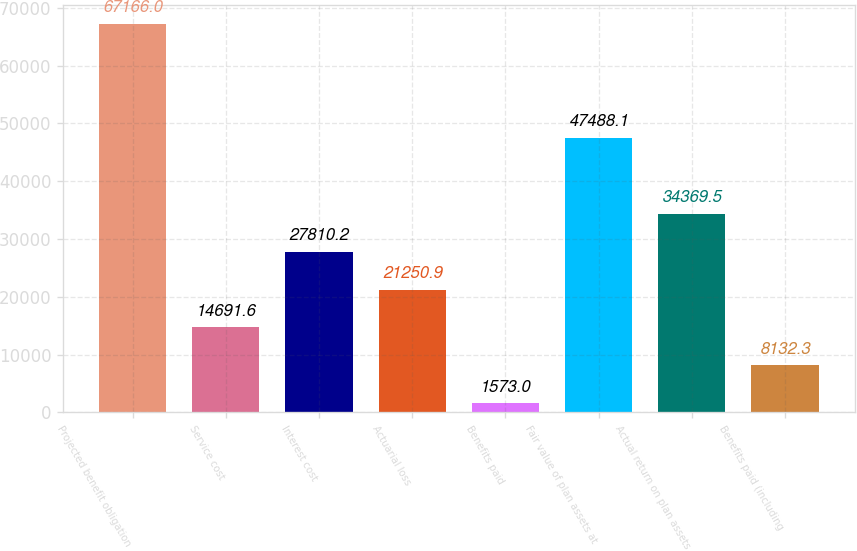Convert chart to OTSL. <chart><loc_0><loc_0><loc_500><loc_500><bar_chart><fcel>Projected benefit obligation<fcel>Service cost<fcel>Interest cost<fcel>Actuarial loss<fcel>Benefits paid<fcel>Fair value of plan assets at<fcel>Actual return on plan assets<fcel>Benefits paid (including<nl><fcel>67166<fcel>14691.6<fcel>27810.2<fcel>21250.9<fcel>1573<fcel>47488.1<fcel>34369.5<fcel>8132.3<nl></chart> 